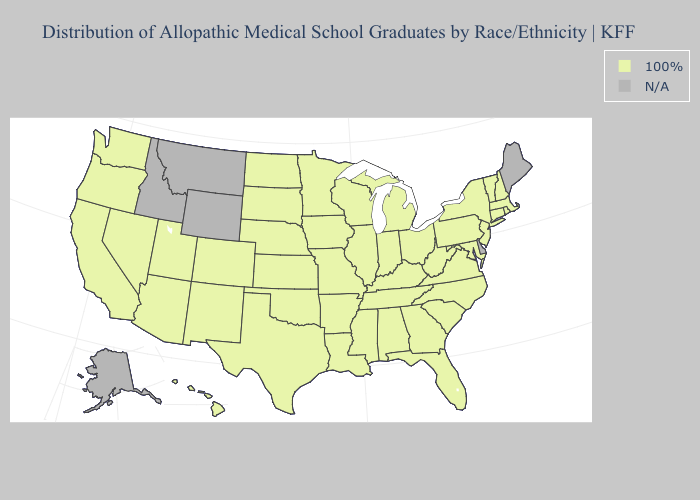What is the lowest value in states that border Pennsylvania?
Give a very brief answer. 100%. Does the map have missing data?
Keep it brief. Yes. What is the highest value in states that border Louisiana?
Concise answer only. 100%. What is the highest value in the USA?
Give a very brief answer. 100%. Name the states that have a value in the range N/A?
Give a very brief answer. Alaska, Delaware, Idaho, Maine, Montana, Wyoming. How many symbols are there in the legend?
Be succinct. 2. Name the states that have a value in the range 100%?
Write a very short answer. Alabama, Arizona, Arkansas, California, Colorado, Connecticut, Florida, Georgia, Hawaii, Illinois, Indiana, Iowa, Kansas, Kentucky, Louisiana, Maryland, Massachusetts, Michigan, Minnesota, Mississippi, Missouri, Nebraska, Nevada, New Hampshire, New Jersey, New Mexico, New York, North Carolina, North Dakota, Ohio, Oklahoma, Oregon, Pennsylvania, Rhode Island, South Carolina, South Dakota, Tennessee, Texas, Utah, Vermont, Virginia, Washington, West Virginia, Wisconsin. Is the legend a continuous bar?
Answer briefly. No. Name the states that have a value in the range N/A?
Concise answer only. Alaska, Delaware, Idaho, Maine, Montana, Wyoming. What is the lowest value in states that border Nebraska?
Short answer required. 100%. How many symbols are there in the legend?
Short answer required. 2. 